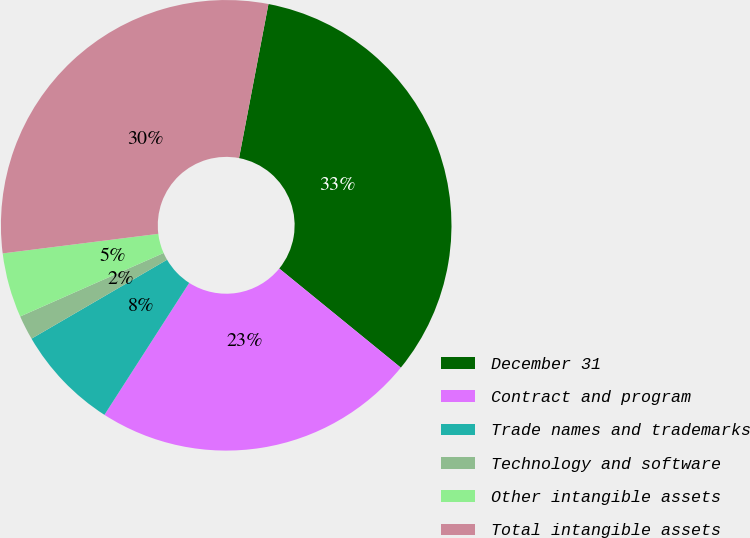<chart> <loc_0><loc_0><loc_500><loc_500><pie_chart><fcel>December 31<fcel>Contract and program<fcel>Trade names and trademarks<fcel>Technology and software<fcel>Other intangible assets<fcel>Total intangible assets<nl><fcel>32.88%<fcel>23.2%<fcel>7.52%<fcel>1.76%<fcel>4.64%<fcel>29.99%<nl></chart> 